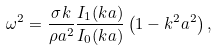<formula> <loc_0><loc_0><loc_500><loc_500>\omega ^ { 2 } = { \frac { \sigma k } { \rho a ^ { 2 } } } { \frac { I _ { 1 } ( k a ) } { I _ { 0 } ( k a ) } } \left ( 1 - k ^ { 2 } a ^ { 2 } \right ) ,</formula> 